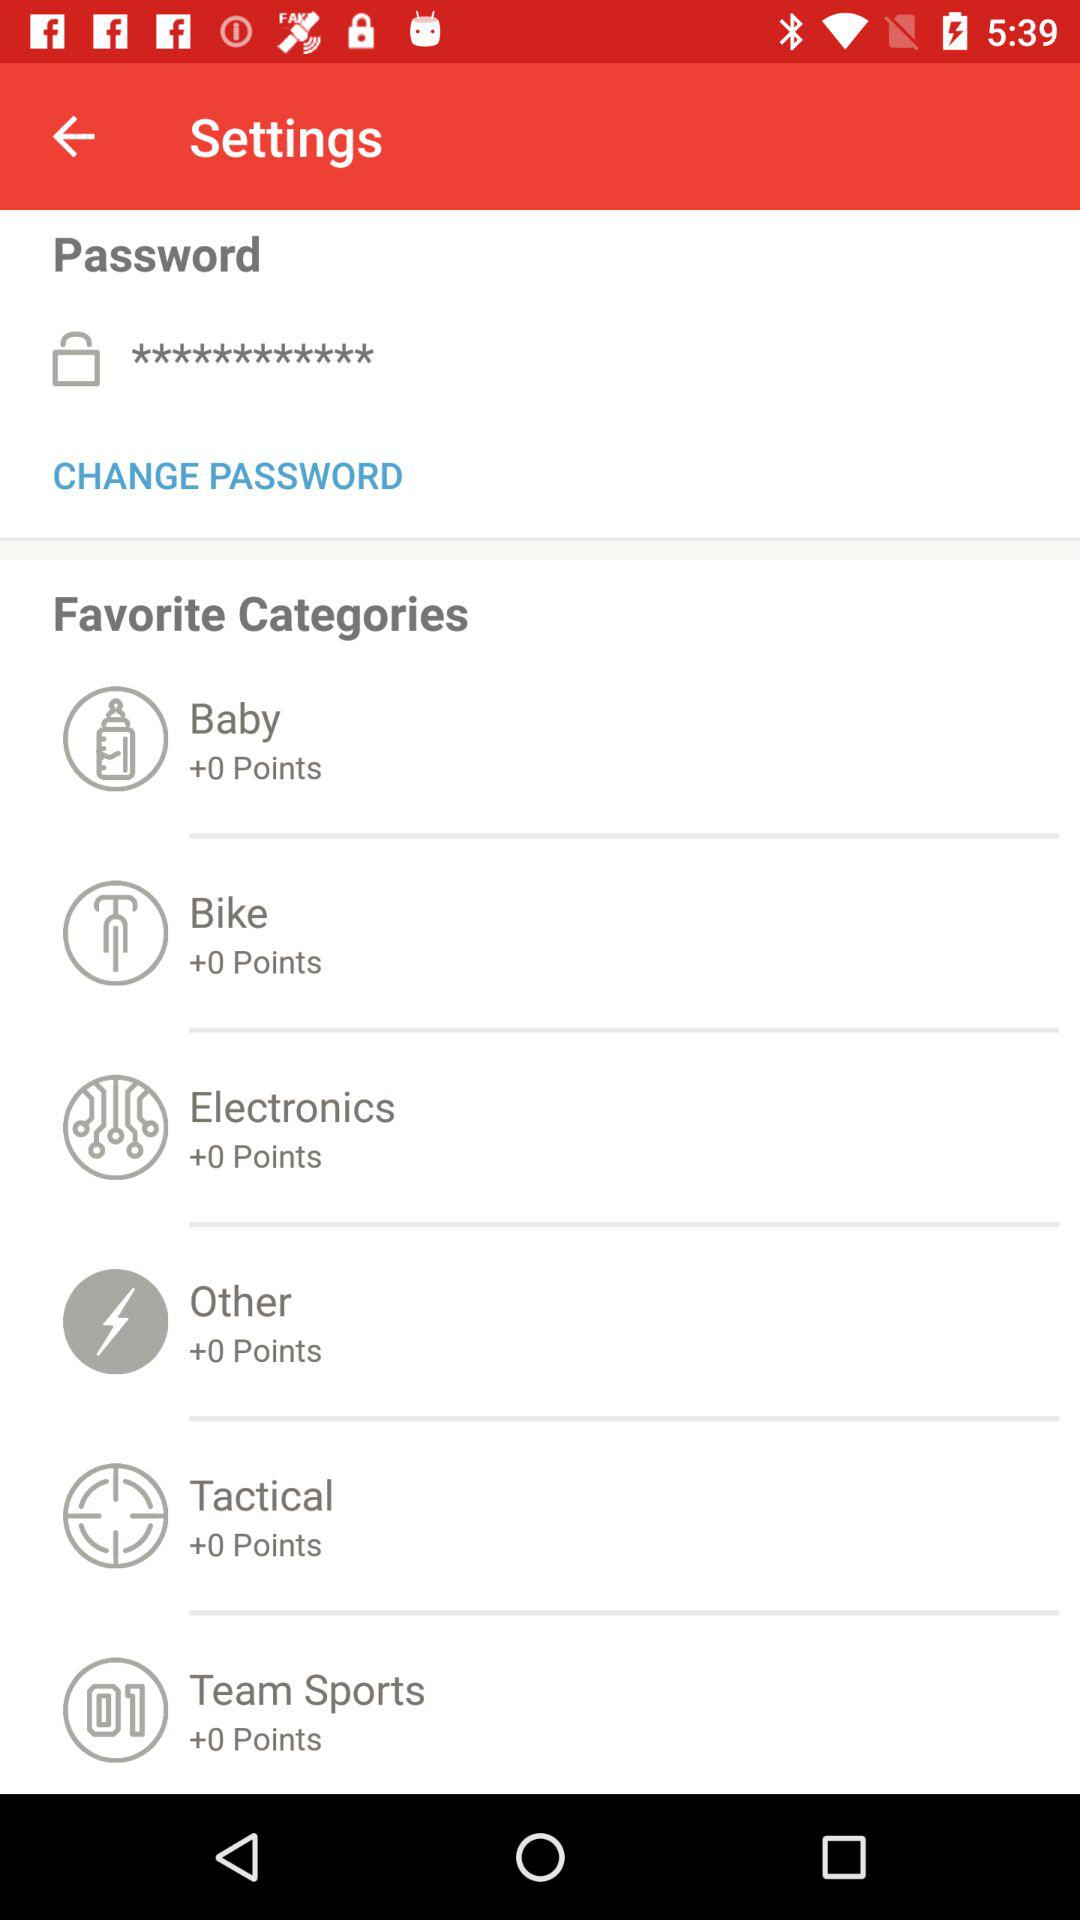How many favorite categories are there?
Answer the question using a single word or phrase. 6 